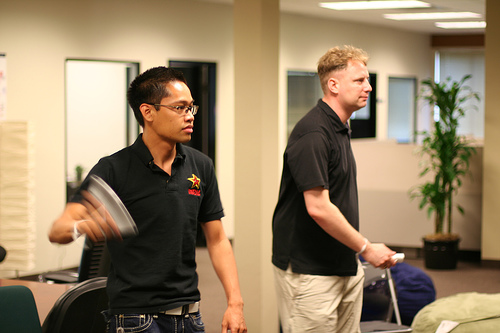Who is wearing jeans? In the image, the man on the right, who appears focused and engaged, is wearing jeans. 